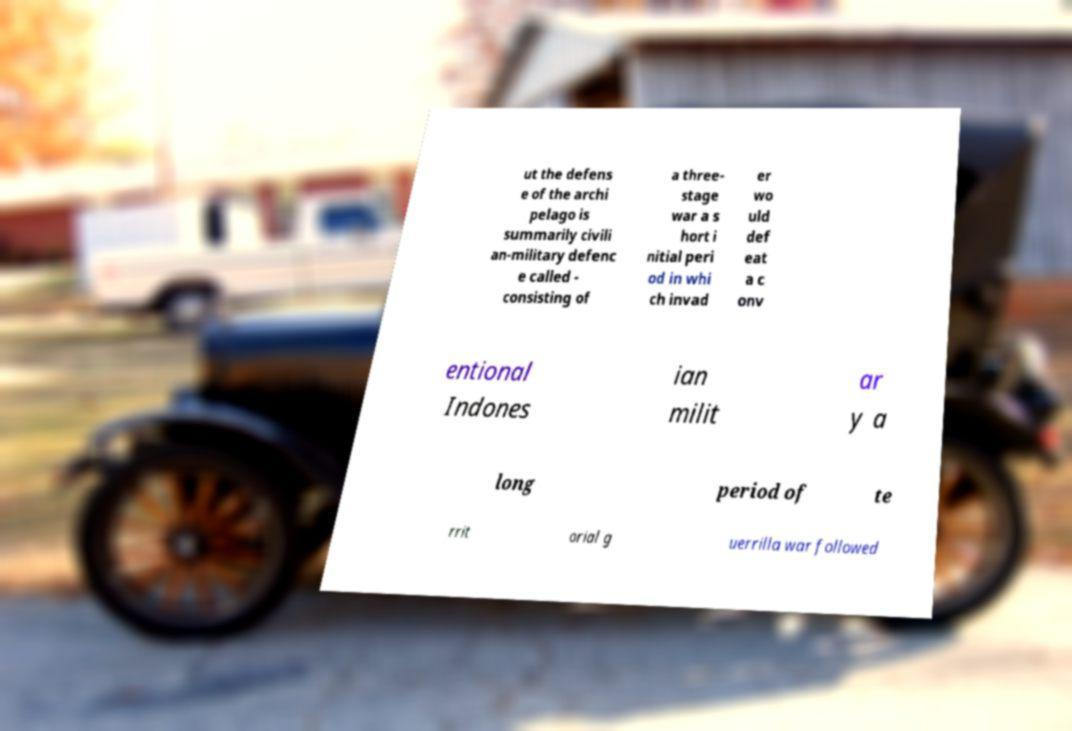I need the written content from this picture converted into text. Can you do that? ut the defens e of the archi pelago is summarily civili an-military defenc e called - consisting of a three- stage war a s hort i nitial peri od in whi ch invad er wo uld def eat a c onv entional Indones ian milit ar y a long period of te rrit orial g uerrilla war followed 